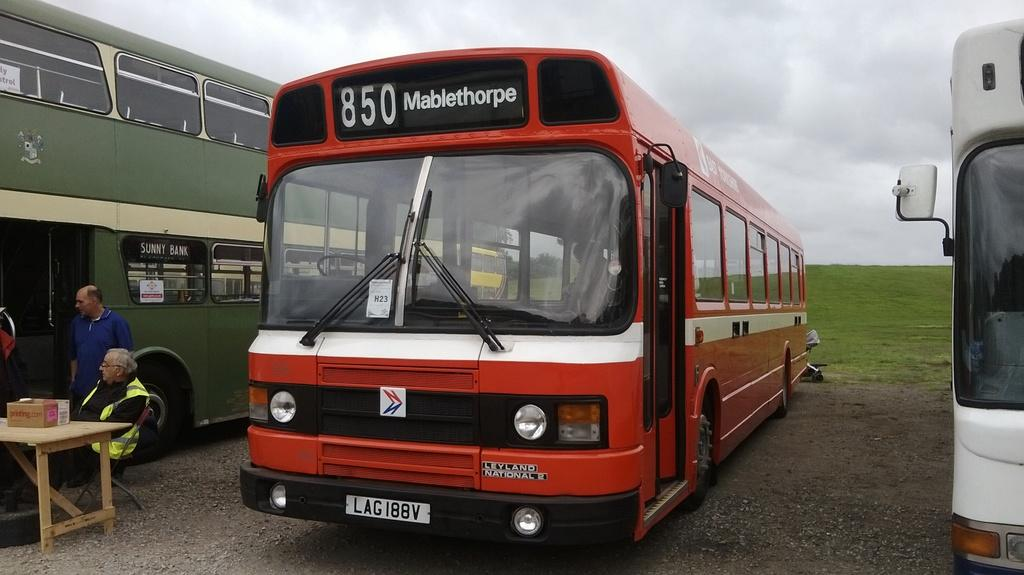How many buses are in the image? There are three buses in the image. Can you describe the people to the right of the red bus? There are two people to the right of the red bus. What can be seen in the background of the image? There is a sky visible in the background of the image. What type of pet can be seen sitting on the roof of the blue bus? There is no pet visible on any of the buses in the image. 